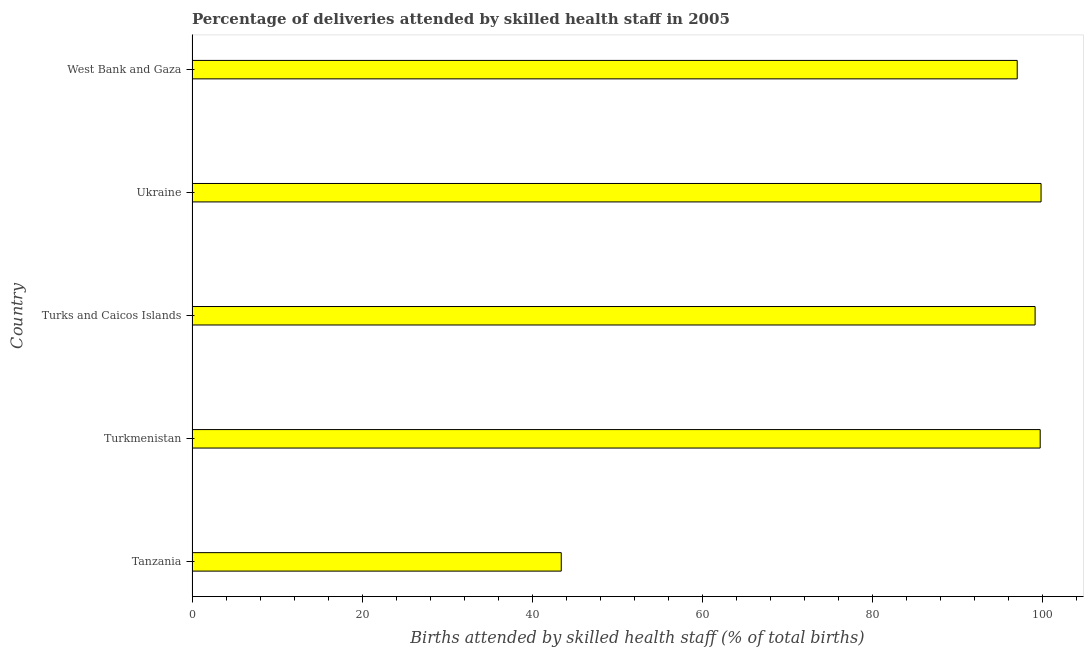Does the graph contain any zero values?
Provide a succinct answer. No. Does the graph contain grids?
Provide a succinct answer. No. What is the title of the graph?
Your answer should be compact. Percentage of deliveries attended by skilled health staff in 2005. What is the label or title of the X-axis?
Your answer should be very brief. Births attended by skilled health staff (% of total births). What is the label or title of the Y-axis?
Your answer should be compact. Country. What is the number of births attended by skilled health staff in Tanzania?
Give a very brief answer. 43.4. Across all countries, what is the maximum number of births attended by skilled health staff?
Your answer should be compact. 99.8. Across all countries, what is the minimum number of births attended by skilled health staff?
Provide a short and direct response. 43.4. In which country was the number of births attended by skilled health staff maximum?
Ensure brevity in your answer.  Ukraine. In which country was the number of births attended by skilled health staff minimum?
Provide a succinct answer. Tanzania. What is the sum of the number of births attended by skilled health staff?
Make the answer very short. 439. What is the difference between the number of births attended by skilled health staff in Tanzania and Turkmenistan?
Offer a terse response. -56.3. What is the average number of births attended by skilled health staff per country?
Your answer should be very brief. 87.8. What is the median number of births attended by skilled health staff?
Make the answer very short. 99.1. In how many countries, is the number of births attended by skilled health staff greater than 80 %?
Offer a terse response. 4. What is the ratio of the number of births attended by skilled health staff in Ukraine to that in West Bank and Gaza?
Your answer should be compact. 1.03. Is the number of births attended by skilled health staff in Turkmenistan less than that in Turks and Caicos Islands?
Ensure brevity in your answer.  No. Is the difference between the number of births attended by skilled health staff in Tanzania and Turks and Caicos Islands greater than the difference between any two countries?
Your answer should be compact. No. Is the sum of the number of births attended by skilled health staff in Turks and Caicos Islands and West Bank and Gaza greater than the maximum number of births attended by skilled health staff across all countries?
Offer a terse response. Yes. What is the difference between the highest and the lowest number of births attended by skilled health staff?
Your response must be concise. 56.4. Are all the bars in the graph horizontal?
Provide a succinct answer. Yes. How many countries are there in the graph?
Your answer should be very brief. 5. What is the Births attended by skilled health staff (% of total births) in Tanzania?
Provide a short and direct response. 43.4. What is the Births attended by skilled health staff (% of total births) of Turkmenistan?
Provide a succinct answer. 99.7. What is the Births attended by skilled health staff (% of total births) of Turks and Caicos Islands?
Your answer should be compact. 99.1. What is the Births attended by skilled health staff (% of total births) in Ukraine?
Give a very brief answer. 99.8. What is the Births attended by skilled health staff (% of total births) in West Bank and Gaza?
Provide a succinct answer. 97. What is the difference between the Births attended by skilled health staff (% of total births) in Tanzania and Turkmenistan?
Your answer should be compact. -56.3. What is the difference between the Births attended by skilled health staff (% of total births) in Tanzania and Turks and Caicos Islands?
Offer a very short reply. -55.7. What is the difference between the Births attended by skilled health staff (% of total births) in Tanzania and Ukraine?
Your answer should be compact. -56.4. What is the difference between the Births attended by skilled health staff (% of total births) in Tanzania and West Bank and Gaza?
Your answer should be very brief. -53.6. What is the difference between the Births attended by skilled health staff (% of total births) in Turkmenistan and Ukraine?
Provide a short and direct response. -0.1. What is the difference between the Births attended by skilled health staff (% of total births) in Turks and Caicos Islands and Ukraine?
Your answer should be compact. -0.7. What is the difference between the Births attended by skilled health staff (% of total births) in Turks and Caicos Islands and West Bank and Gaza?
Provide a short and direct response. 2.1. What is the difference between the Births attended by skilled health staff (% of total births) in Ukraine and West Bank and Gaza?
Offer a terse response. 2.8. What is the ratio of the Births attended by skilled health staff (% of total births) in Tanzania to that in Turkmenistan?
Keep it short and to the point. 0.43. What is the ratio of the Births attended by skilled health staff (% of total births) in Tanzania to that in Turks and Caicos Islands?
Provide a succinct answer. 0.44. What is the ratio of the Births attended by skilled health staff (% of total births) in Tanzania to that in Ukraine?
Keep it short and to the point. 0.43. What is the ratio of the Births attended by skilled health staff (% of total births) in Tanzania to that in West Bank and Gaza?
Keep it short and to the point. 0.45. What is the ratio of the Births attended by skilled health staff (% of total births) in Turkmenistan to that in West Bank and Gaza?
Keep it short and to the point. 1.03. What is the ratio of the Births attended by skilled health staff (% of total births) in Turks and Caicos Islands to that in West Bank and Gaza?
Offer a terse response. 1.02. 